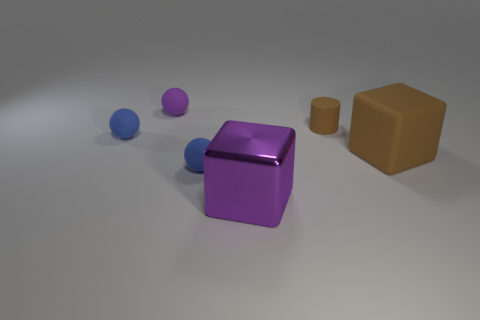Is the tiny ball in front of the large matte block made of the same material as the big purple block?
Your answer should be compact. No. What size is the blue matte object right of the tiny blue rubber ball on the left side of the purple thing on the left side of the big purple metal block?
Your response must be concise. Small. What is the shape of the other brown thing that is the same size as the shiny thing?
Make the answer very short. Cube. There is a thing that is behind the tiny brown rubber cylinder; what size is it?
Provide a short and direct response. Small. There is a large block that is right of the big purple cube; is its color the same as the small thing behind the matte cylinder?
Provide a succinct answer. No. There is a purple thing that is in front of the blue rubber sphere in front of the rubber thing that is on the right side of the tiny brown matte thing; what is it made of?
Make the answer very short. Metal. Are there any purple balls of the same size as the purple shiny object?
Provide a short and direct response. No. There is a brown cylinder that is the same size as the purple rubber thing; what material is it?
Make the answer very short. Rubber. What is the shape of the purple thing that is in front of the purple sphere?
Your answer should be very brief. Cube. Does the small purple sphere to the left of the metallic block have the same material as the small blue object in front of the large brown matte thing?
Provide a short and direct response. Yes. 